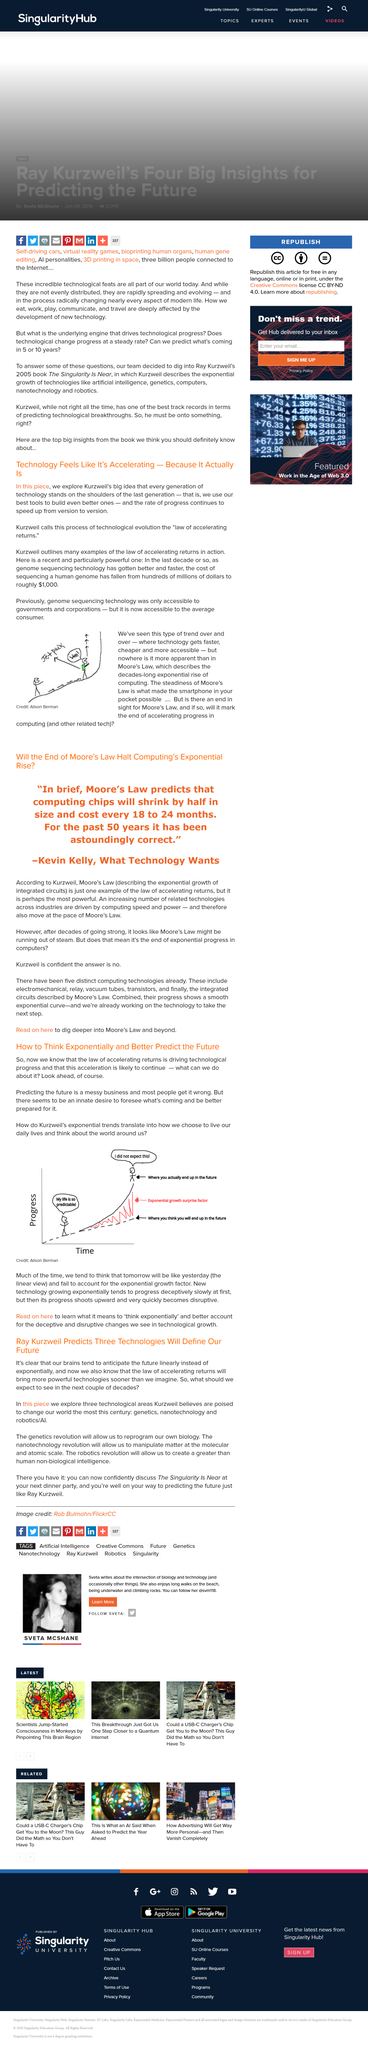Outline some significant characteristics in this image. Kurzweil refers to the "law of accelerating returns," using the most advanced tools available to create even more advanced ones. It has taken approximately a decade for the cost of sequencing the human genome to decrease from hundreds of millions of dollars to $1000. The cost of sequencing a human genome is currently approximately $1,000. 